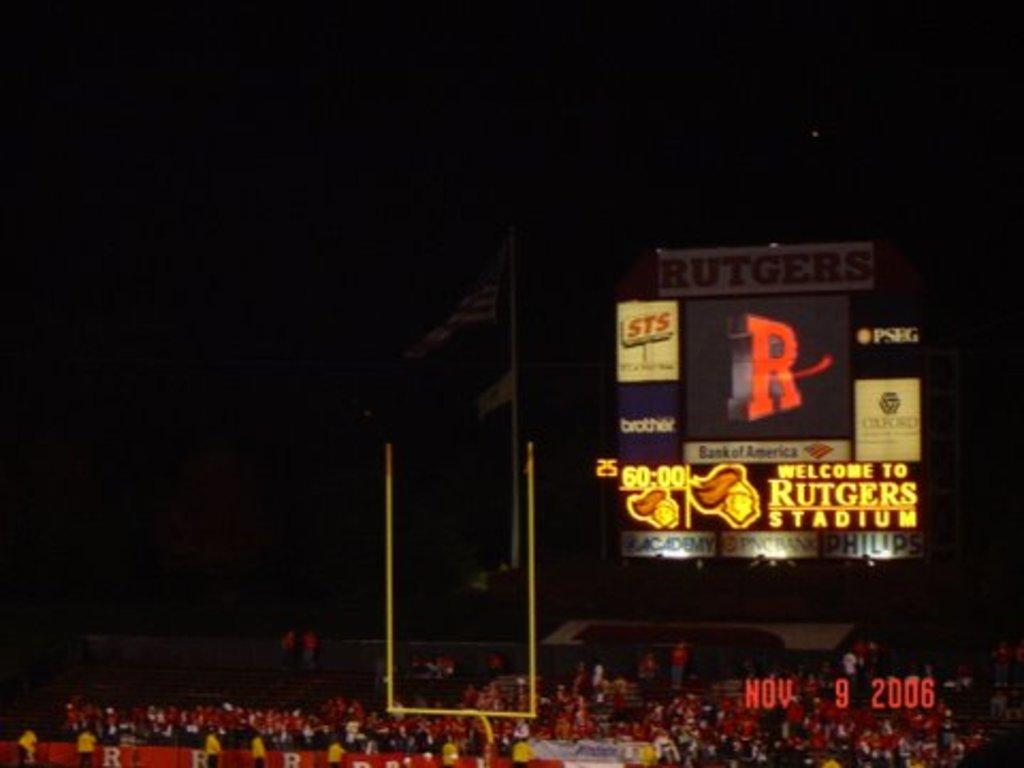<image>
Give a short and clear explanation of the subsequent image. The Rutgers football stadium with an advertisement for Bank of America 